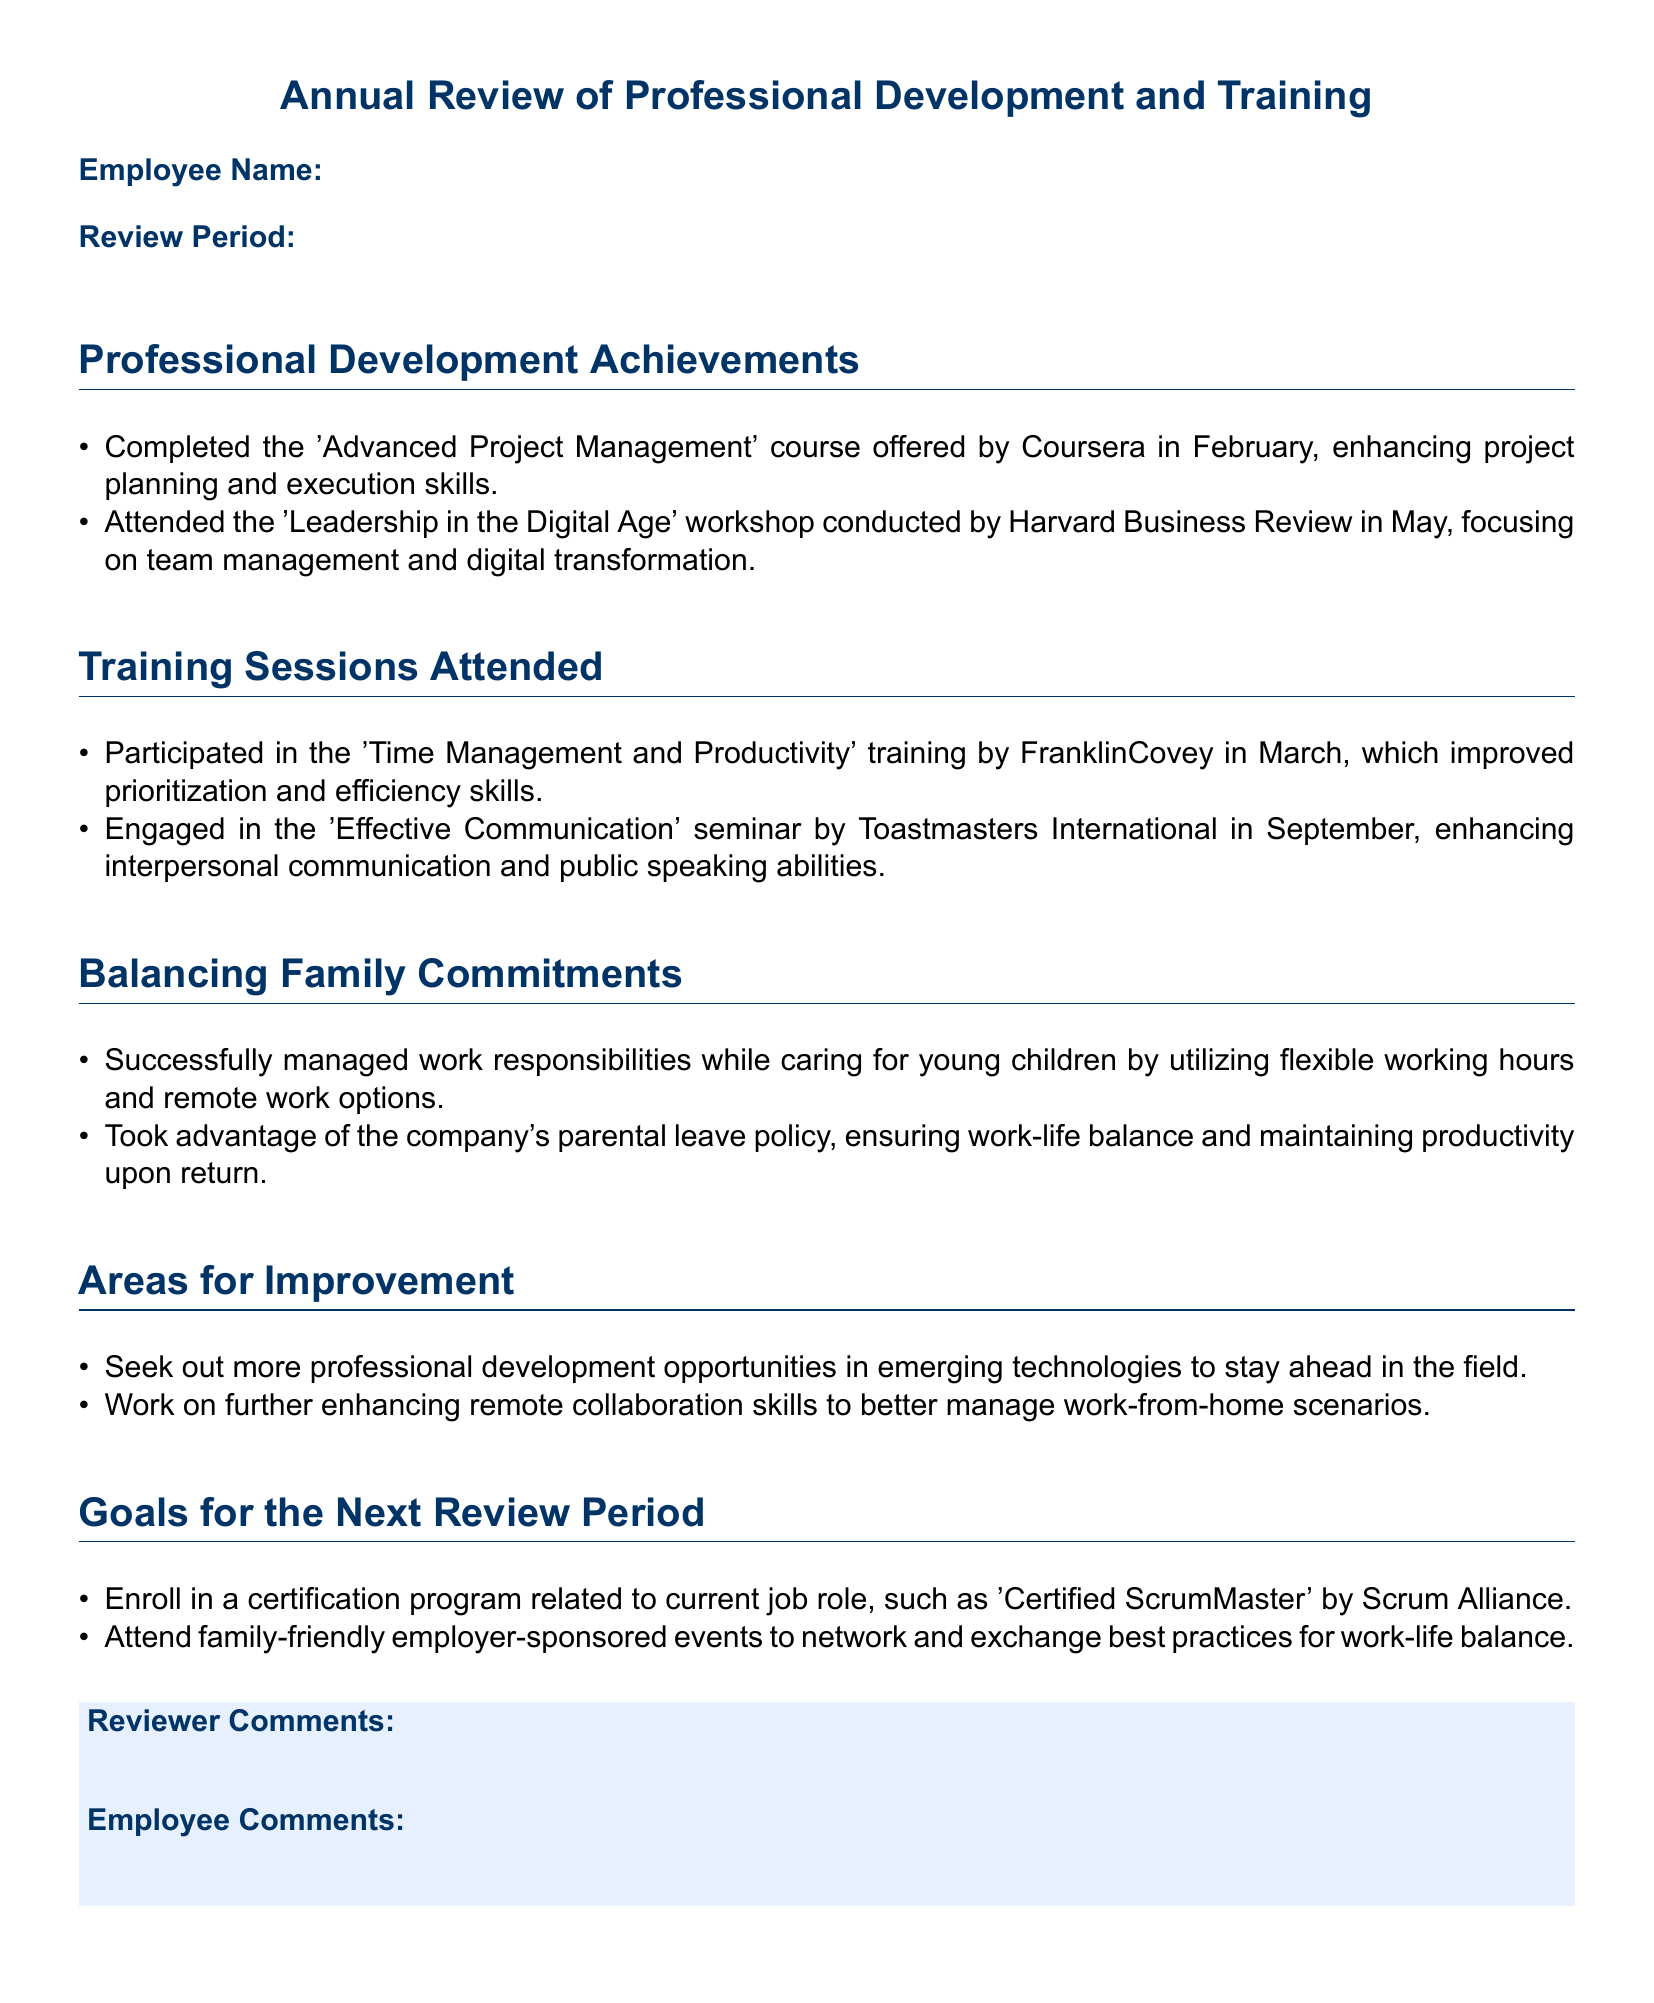What course did the employee complete in February? The document mentions "Advanced Project Management" course completed by the employee in February.
Answer: Advanced Project Management What workshop was attended in May? The document states the employee attended the "Leadership in the Digital Age" workshop in May.
Answer: Leadership in the Digital Age What training did the employee participate in March? The document specifies the "Time Management and Productivity" training attended by the employee in March.
Answer: Time Management and Productivity What policy did the employee utilize for work-life balance? The document indicates that the employee took advantage of the company's "parental leave policy" to maintain work-life balance.
Answer: parental leave policy What is one area identified for improvement? The document notes that the employee wants to seek more professional development opportunities in emerging technologies.
Answer: seek more professional development opportunities in emerging technologies What certification program does the employee plan to enroll in? The document mentions that the employee aims to enroll in the "Certified ScrumMaster" by Scrum Alliance.
Answer: Certified ScrumMaster What is the purpose of attending family-friendly employer-sponsored events? The document states that attending these events is for networking and exchanging best practices for work-life balance.
Answer: networking and exchanging best practices for work-life balance How does the document categorize professional development? The document has a section titled "Professional Development Achievements" highlighting completed courses and workshops.
Answer: Professional Development Achievements 